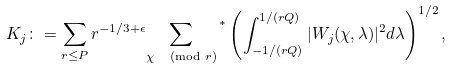<formula> <loc_0><loc_0><loc_500><loc_500>K _ { j } \colon = \sum _ { r \leq P } r ^ { - 1 / 3 + \epsilon } { \sum _ { \chi \, \pmod { r } } } ^ { \, * } \left ( \int _ { - 1 / ( r Q ) } ^ { 1 / ( r Q ) } | W _ { j } ( \chi , \lambda ) | ^ { 2 } d \lambda \right ) ^ { 1 / 2 } ,</formula> 